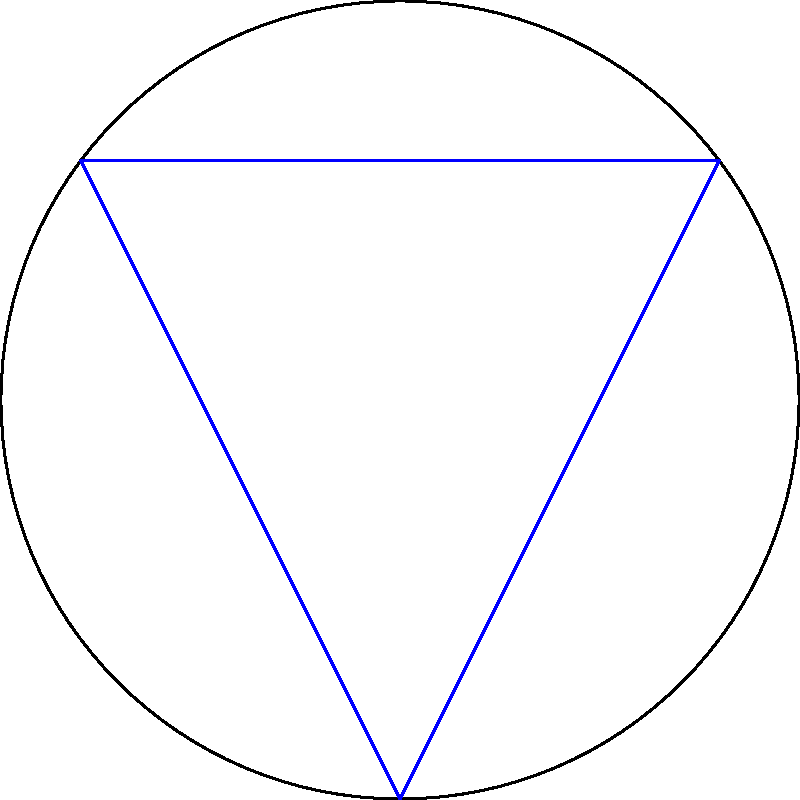Consider a flight path between two points A and B on the Earth's surface, with C being a point directly opposite B on the great circle path from A to B. If the straight-line distance between A and B (chord AB) is 10,000 km, and the Earth's radius is approximately 6,371 km, what is the difference in distance between the great circle path (arc ACB) and the straight-line path (chord AB)? To solve this problem, we'll follow these steps:

1) First, we need to find the central angle $\theta$ subtended by the chord AB:
   Using the chord length formula: $c = 2R \sin(\frac{\theta}{2})$
   Where $c$ is the chord length, $R$ is the Earth's radius, and $\theta$ is in radians.

   $10000 = 2 \cdot 6371 \cdot \sin(\frac{\theta}{2})$
   $\frac{10000}{2 \cdot 6371} = \sin(\frac{\theta}{2})$
   $\frac{\theta}{2} = \arcsin(\frac{10000}{2 \cdot 6371}) \approx 0.7854$
   $\theta \approx 1.5708$ radians or $90°$

2) Now that we know the central angle, we can calculate the length of the great circle arc:
   Arc length = $R\theta = 6371 \cdot 1.5708 \approx 10,007.5$ km

3) The difference between the great circle path and the straight-line path is:
   $10,007.5 - 10,000 = 7.5$ km

This difference illustrates the curvature of the Earth's surface and its effect on flight paths. The great circle route, while appearing curved on a flat map, is actually the shortest path between two points on a sphere.
Answer: 7.5 km 